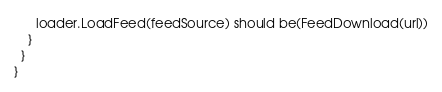<code> <loc_0><loc_0><loc_500><loc_500><_Scala_>      loader.LoadFeed(feedSource) should be(FeedDownload(url))
    }
  }
}
</code> 